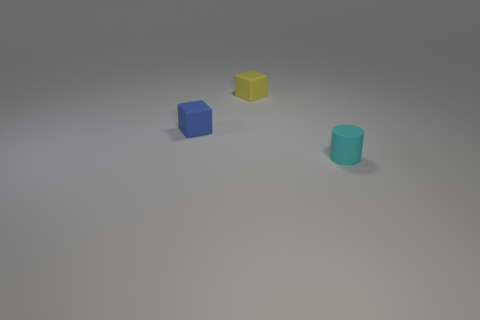Are there fewer cyan matte cylinders to the right of the tiny matte cylinder than tiny blocks on the left side of the small yellow cube?
Keep it short and to the point. Yes. What number of tiny matte objects are there?
Provide a succinct answer. 3. There is a rubber thing that is behind the blue rubber object; what color is it?
Offer a very short reply. Yellow. The blue cube is what size?
Your response must be concise. Small. Does the matte cylinder have the same color as the small block that is behind the tiny blue thing?
Offer a terse response. No. There is a tiny matte cube behind the tiny block that is left of the small yellow cube; what is its color?
Give a very brief answer. Yellow. Are there any other things that are the same size as the cylinder?
Give a very brief answer. Yes. There is a rubber object that is behind the blue cube; is its shape the same as the blue rubber thing?
Your answer should be compact. Yes. How many matte objects are both on the right side of the yellow thing and left of the small cyan matte object?
Offer a terse response. 0. There is a cube that is on the right side of the matte thing to the left of the small matte thing that is behind the blue cube; what color is it?
Give a very brief answer. Yellow. 